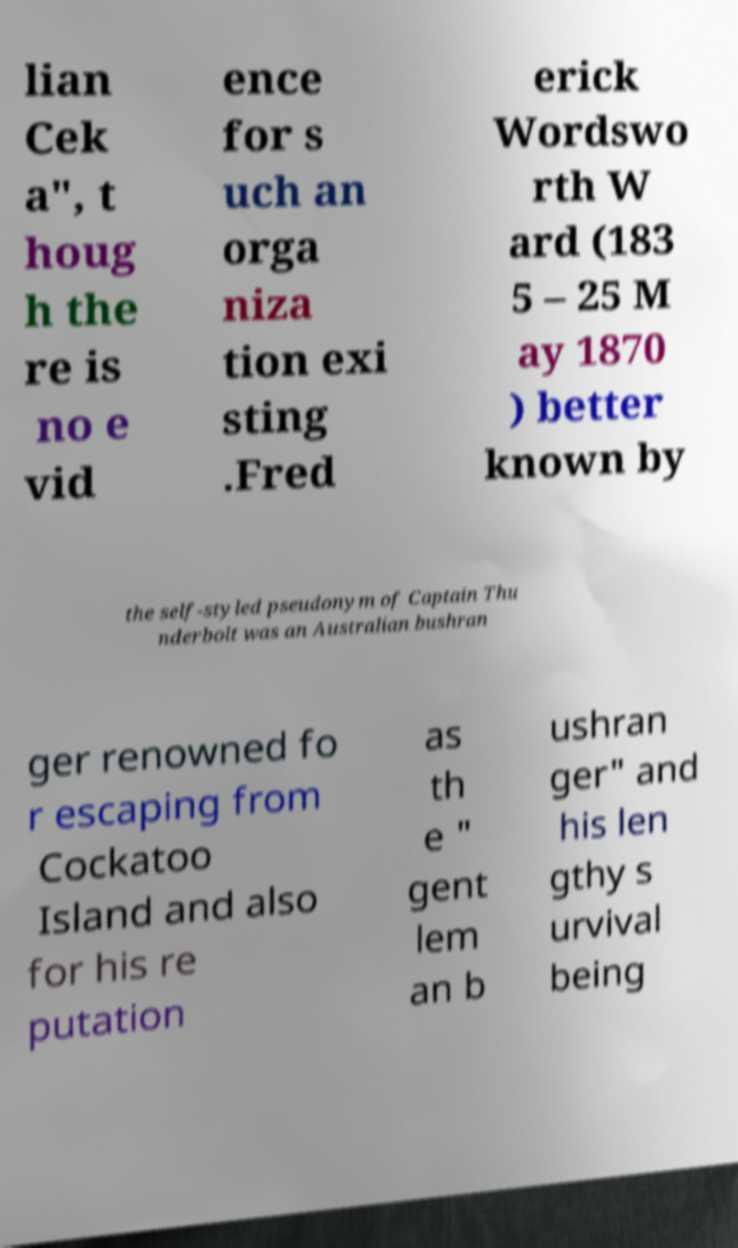Could you extract and type out the text from this image? lian Cek a", t houg h the re is no e vid ence for s uch an orga niza tion exi sting .Fred erick Wordswo rth W ard (183 5 – 25 M ay 1870 ) better known by the self-styled pseudonym of Captain Thu nderbolt was an Australian bushran ger renowned fo r escaping from Cockatoo Island and also for his re putation as th e " gent lem an b ushran ger" and his len gthy s urvival being 